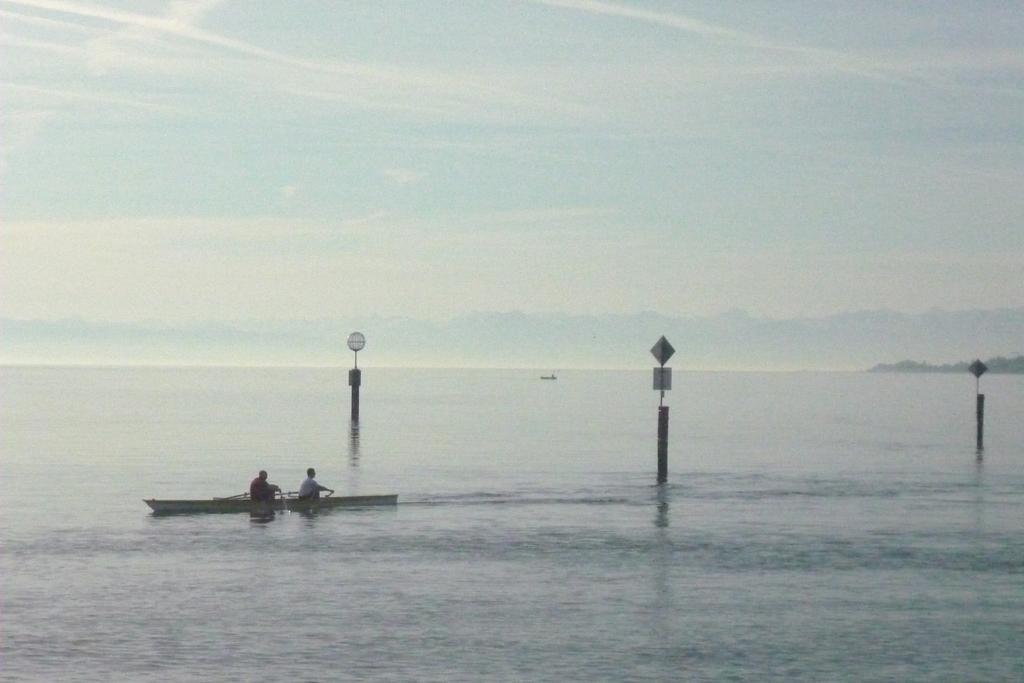Could you give a brief overview of what you see in this image? In the image we can see a boat in the water and in the boat there are two people sitting, wearing clothes. Here we can see the water, poles, boards and the cloudy sky. 